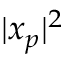Convert formula to latex. <formula><loc_0><loc_0><loc_500><loc_500>| x _ { p } | ^ { 2 }</formula> 